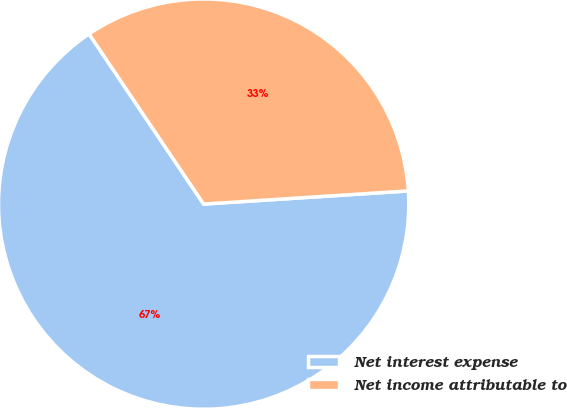<chart> <loc_0><loc_0><loc_500><loc_500><pie_chart><fcel>Net interest expense<fcel>Net income attributable to<nl><fcel>66.59%<fcel>33.41%<nl></chart> 